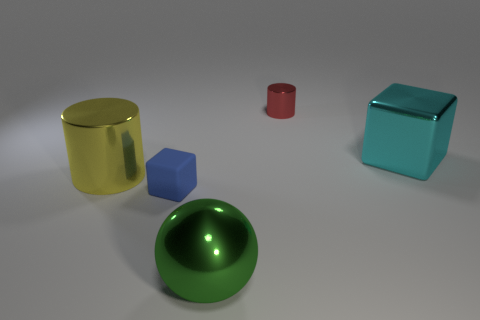Subtract all red cubes. Subtract all gray balls. How many cubes are left? 2 Add 4 big cyan metallic spheres. How many objects exist? 9 Subtract all cylinders. How many objects are left? 3 Subtract all brown metal blocks. Subtract all green shiny spheres. How many objects are left? 4 Add 3 big balls. How many big balls are left? 4 Add 4 yellow metal objects. How many yellow metal objects exist? 5 Subtract 0 green cylinders. How many objects are left? 5 